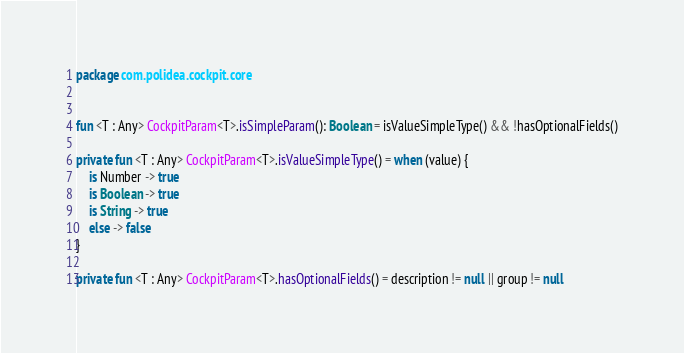<code> <loc_0><loc_0><loc_500><loc_500><_Kotlin_>package com.polidea.cockpit.core


fun <T : Any> CockpitParam<T>.isSimpleParam(): Boolean = isValueSimpleType() && !hasOptionalFields()

private fun <T : Any> CockpitParam<T>.isValueSimpleType() = when (value) {
    is Number -> true
    is Boolean -> true
    is String -> true
    else -> false
}

private fun <T : Any> CockpitParam<T>.hasOptionalFields() = description != null || group != null</code> 